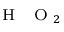<formula> <loc_0><loc_0><loc_500><loc_500>_ { { H } { O } _ { 2 } }</formula> 